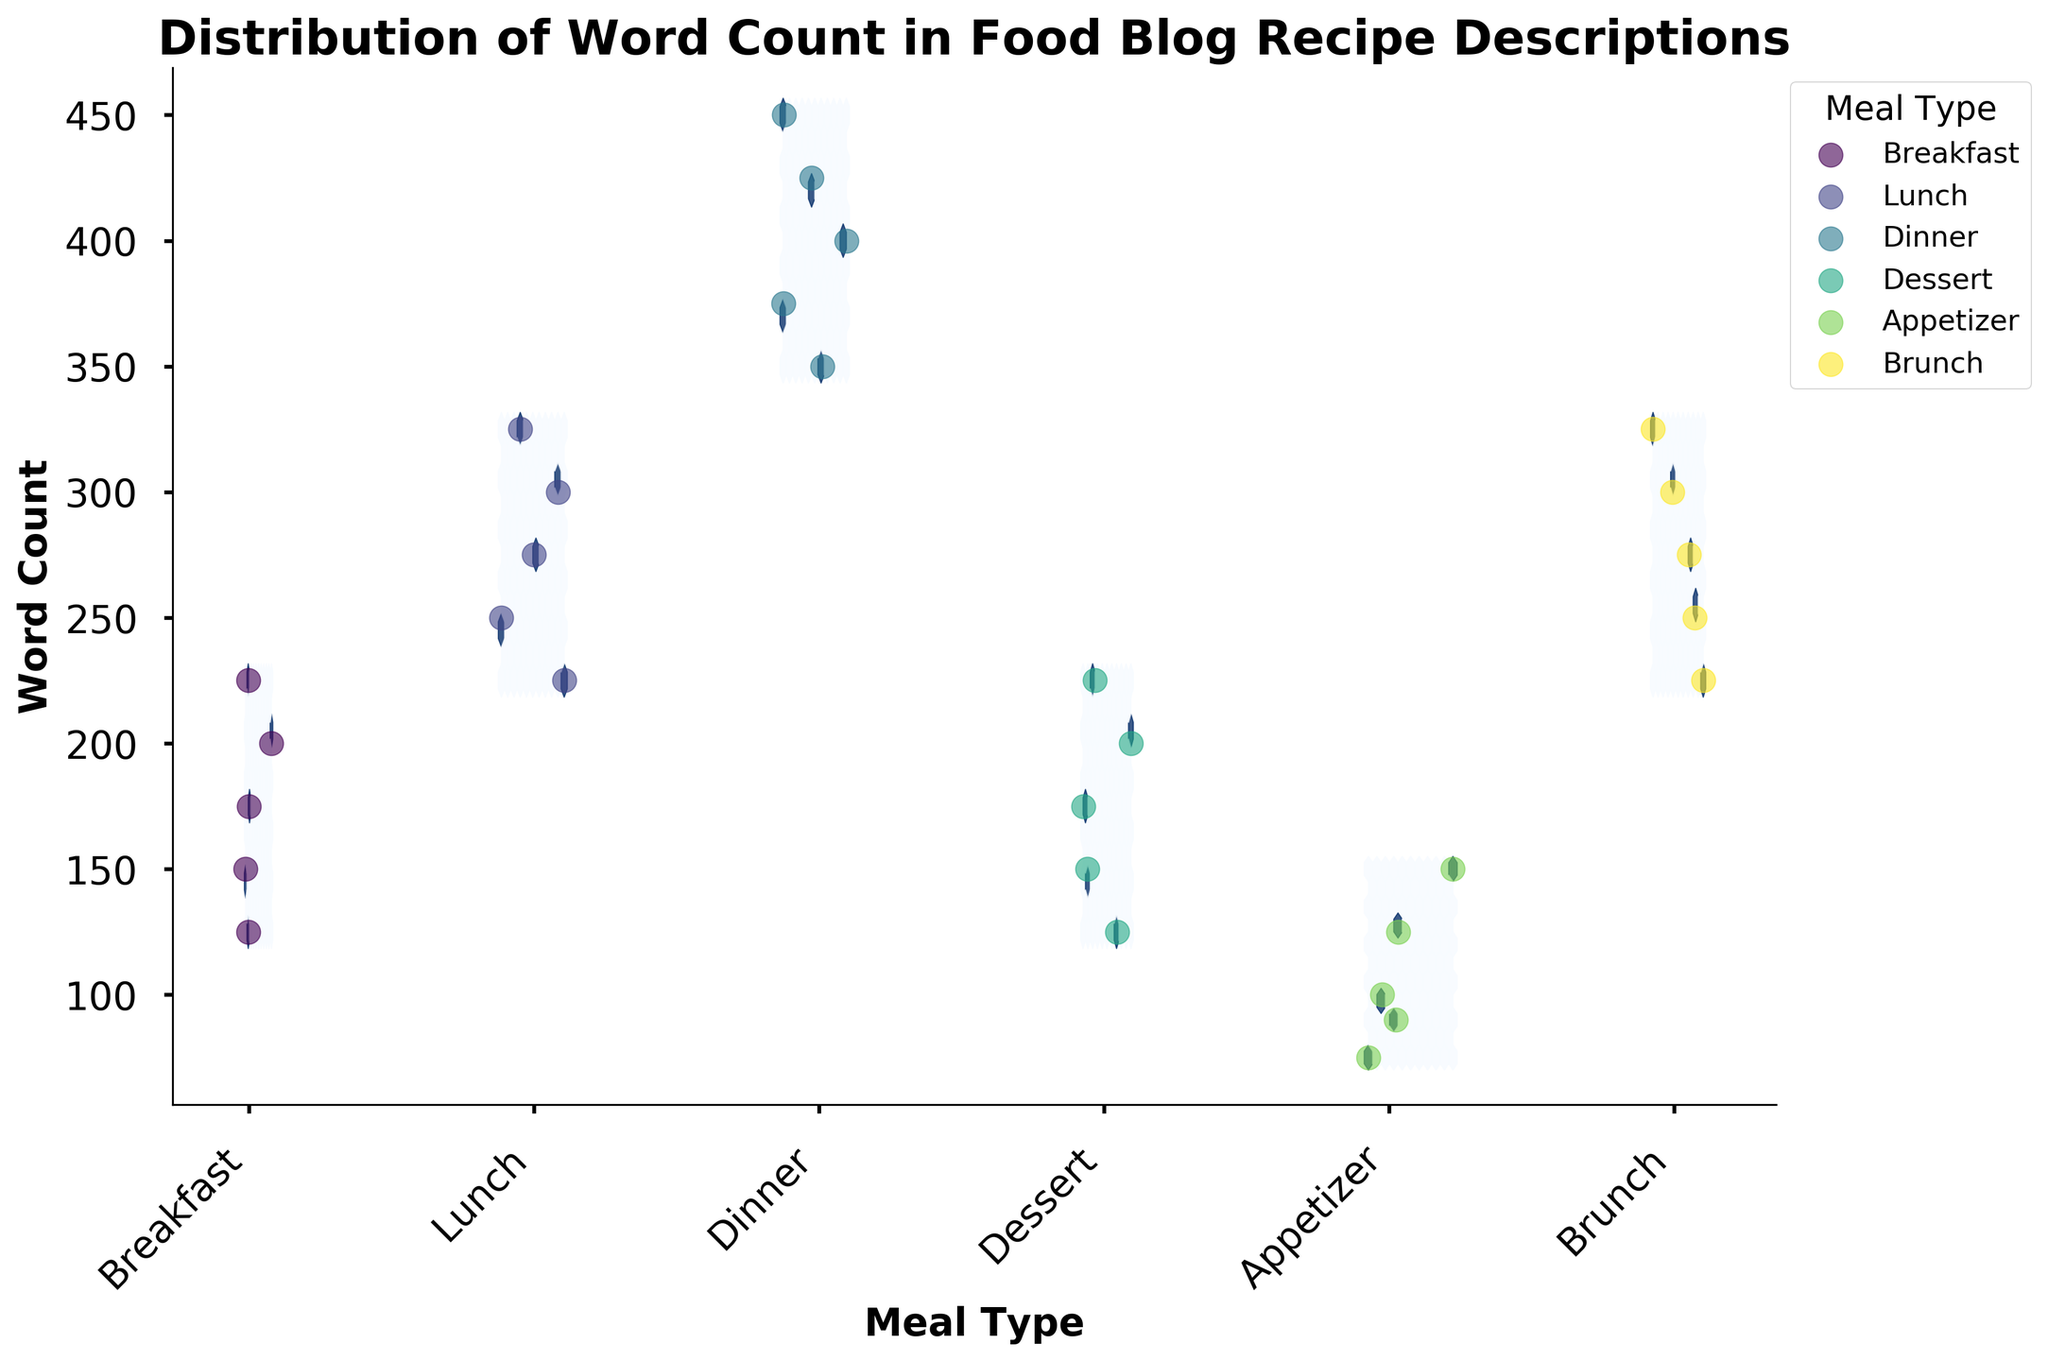What is the title of the figure? The title of the figure is placed usually at the top and is indicated with bold text. Here it states: "Distribution of Word Count in Food Blog Recipe Descriptions."
Answer: Distribution of Word Count in Food Blog Recipe Descriptions Which meal type has the highest word count cluster? In the plot, the shaded hexagons indicate clusters of data points. The densest or darkest-shaded area represents the largest cluster. Dinner shows the highest word count cluster.
Answer: Dinner How is the y-axis labeled? The y-axis typically contains the range of values we are analyzing. In this figure, it is labeled 'Word Count'.
Answer: Word Count What meal types are included in the plot? The xticks with labels correspond to the different meal types plotted. Translating from coding, the meal types included in the plot are Breakfast, Lunch, Dinner, Dessert, Appetizer, and Brunch.
Answer: Breakfast, Lunch, Dinner, Dessert, Appetizer, Brunch What is the average word count for the Breakfast meal type? For averaging, sum up all the word counts for Breakfast and divide by the number of records: (150+200+175+225+125) / 5 = 875 / 5
Answer: 175 Which meal type shows a wider range of word counts: Lunch or Brunch? Observing the spread of data points on the y-axis for both meal types, we see: Brunch (225-325), Lunch (225-325). Both have the same range in the plot.
Answer: Same range Between Breakfast and Dessert, which meal type has more variability in word count? Variability is inferred from how spread out the points are; Breakfast has points ranging from 125 to 225 while Dessert ranges from 125 to 225. Both seem to have the same variability.
Answer: Same variability Describe the color of the hexagons used in the plot. Colors give visual cues on the density of points. The hexagons in this hexbin plot are colored with shades of blue from the color map 'Blues'.
Answer: Shades of blue What information does the color intensity in the hexbin plot convey? The darker shades of blue in the hexagons indicate a higher density of points in that area, meaning more blog descriptions have that word count.
Answer: Density of points Which meal type has the lowest maximum word count? The y-axis reveals the highest word counts for each category. Observing the highest points: Appetizers have the lowest maximum word count of 150.
Answer: Appetizer 